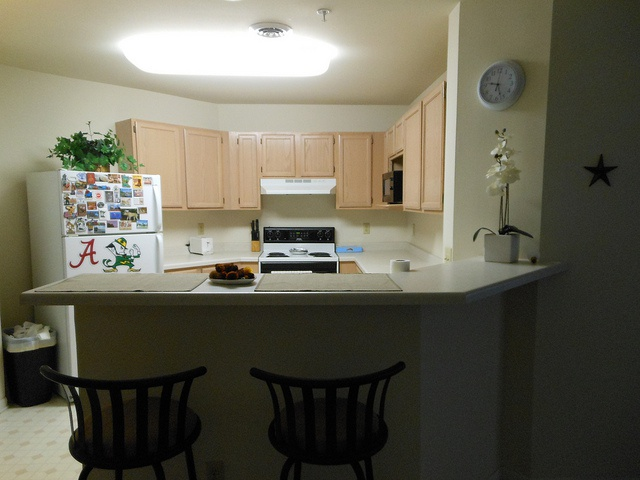Describe the objects in this image and their specific colors. I can see refrigerator in tan, lightgray, darkgray, and gray tones, chair in tan, black, gray, darkgray, and darkgreen tones, chair in black and tan tones, potted plant in tan, gray, black, and darkgreen tones, and oven in tan, black, lightgray, darkgray, and gray tones in this image. 